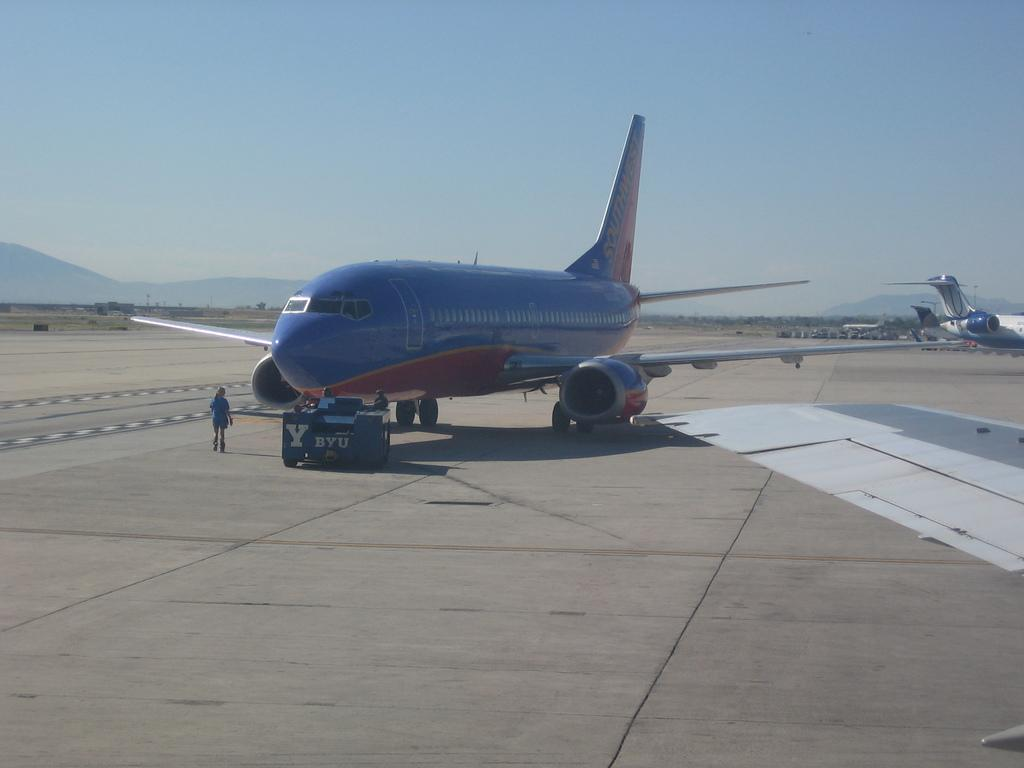<image>
Describe the image concisely. A blue airplane with southwest written on the tail 